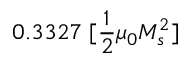<formula> <loc_0><loc_0><loc_500><loc_500>0 . 3 3 2 7 \, [ \frac { 1 } { 2 } \mu _ { 0 } M _ { s } ^ { 2 } ]</formula> 